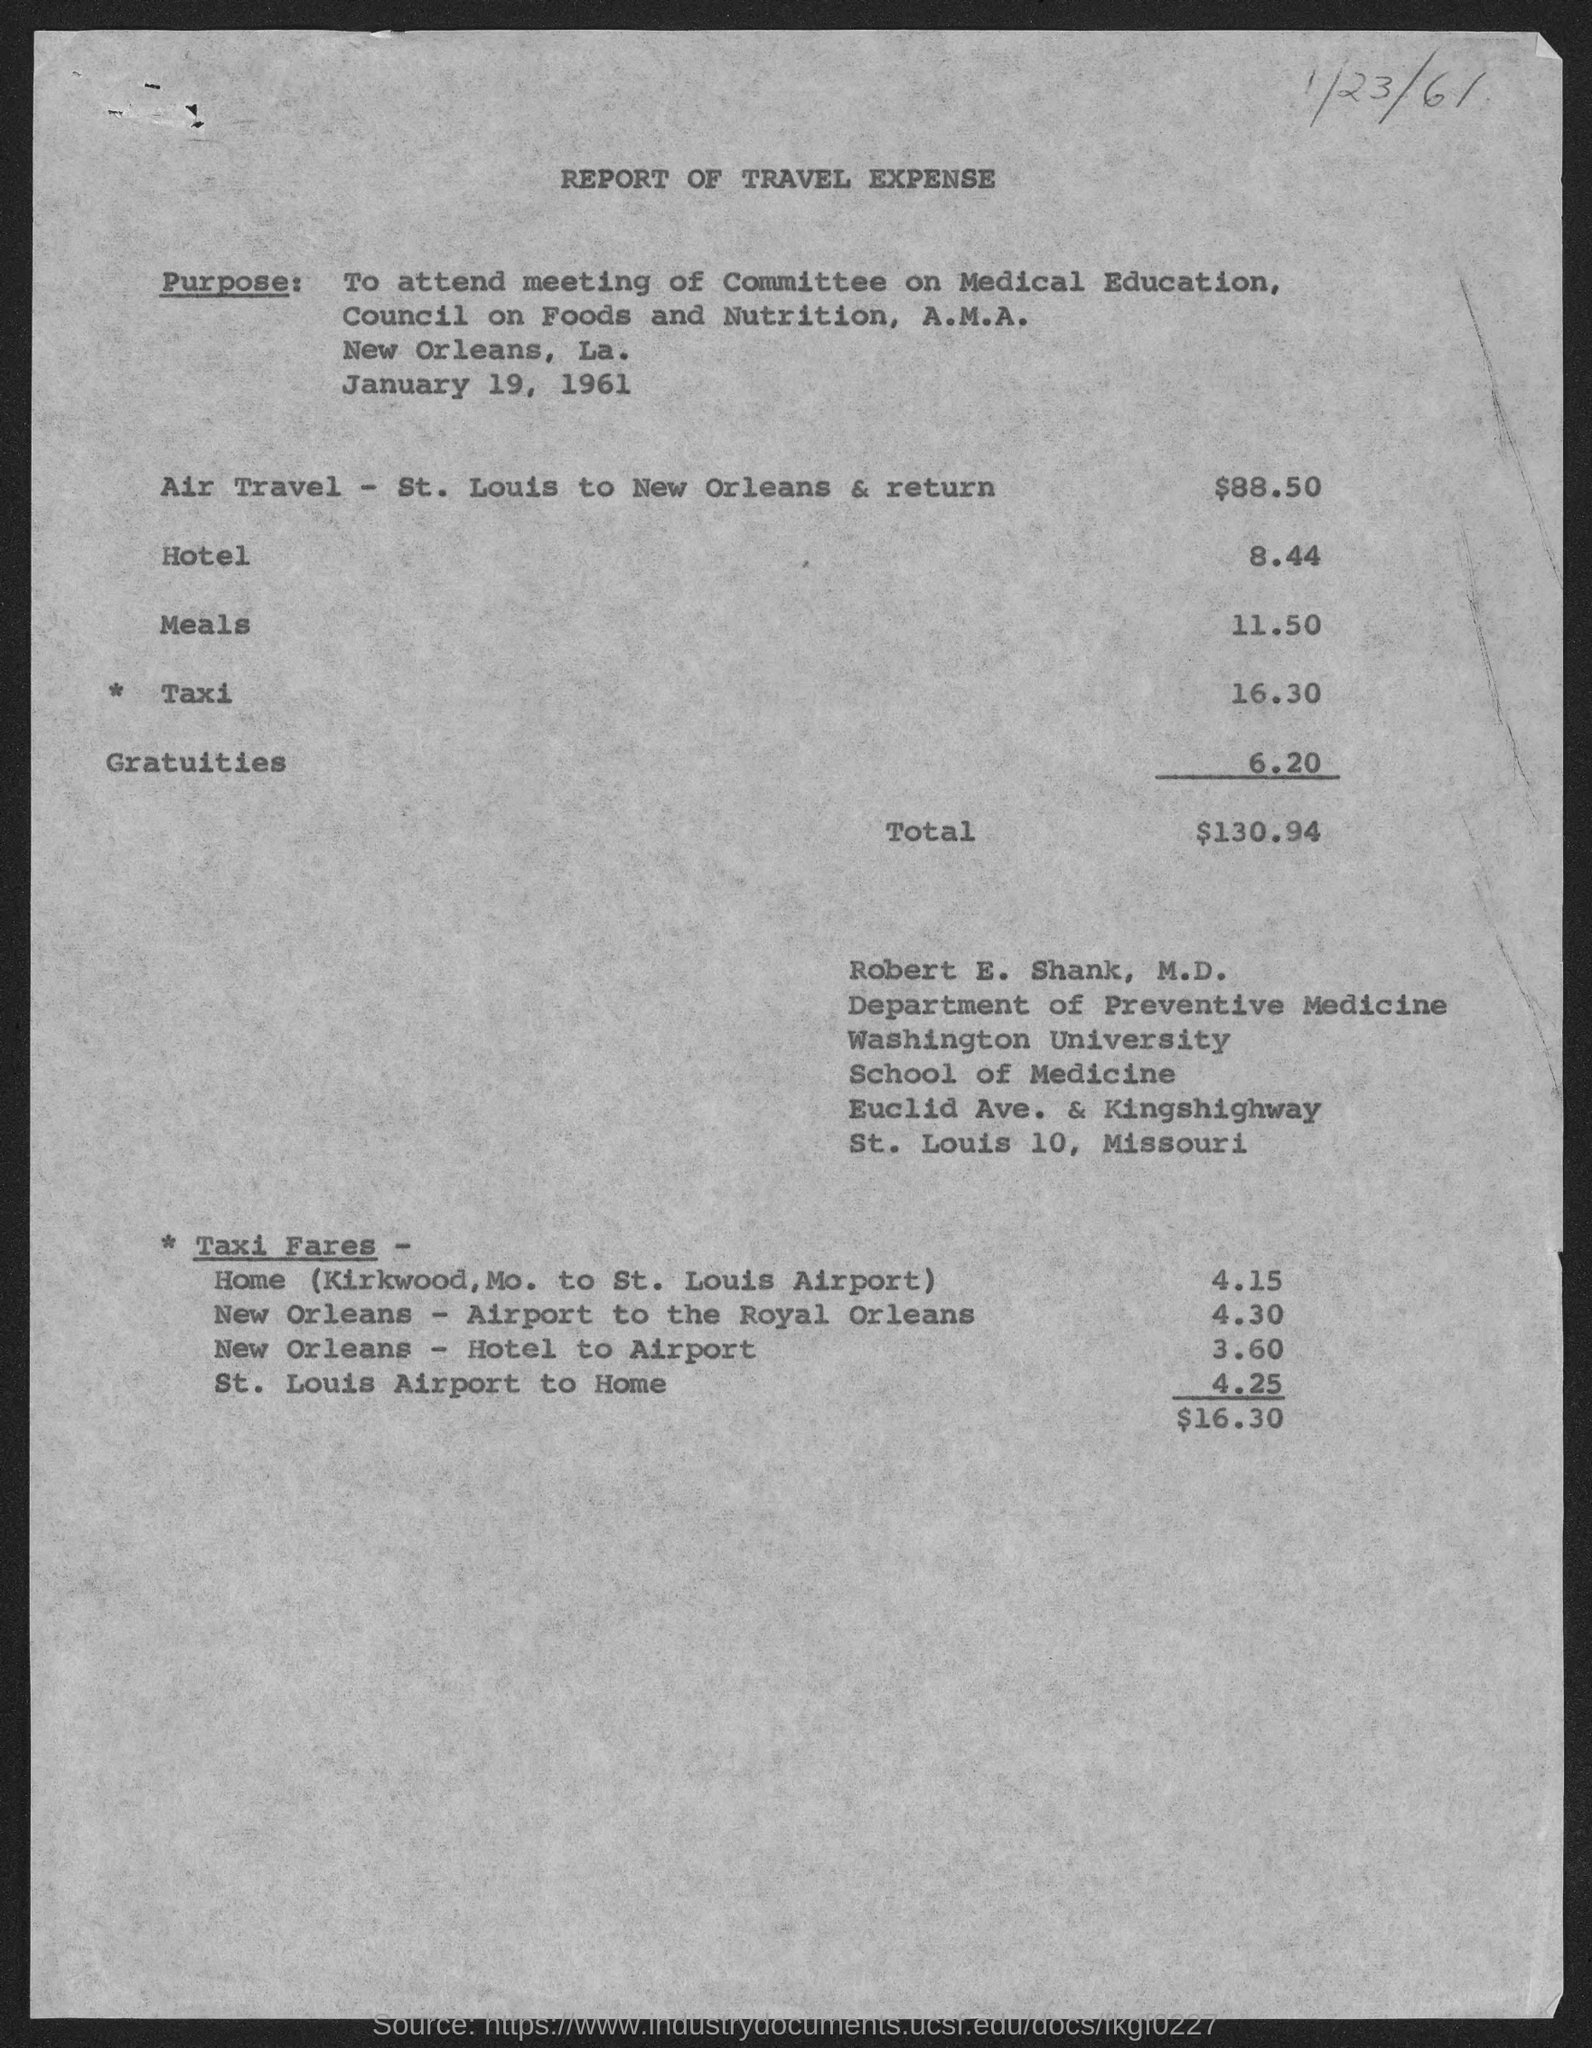What is the air travel expense given in the document?
Provide a succinct answer. $88.50. What is the total travel expense mentioned in the document?
Your answer should be very brief. $130.94. Who's travel expense is given in this document?
Provide a succinct answer. Robert E. Shank,  M.D. 